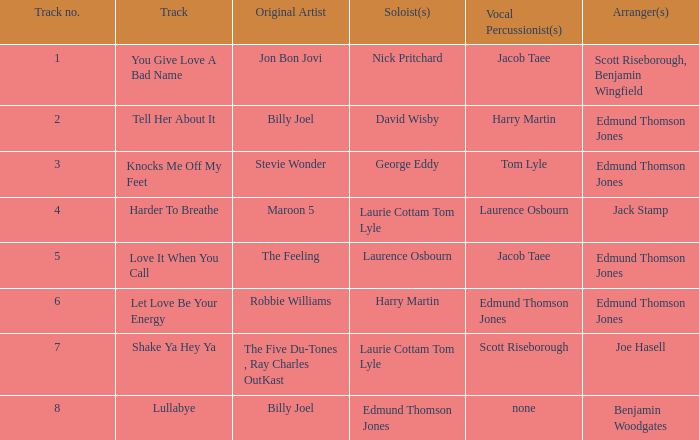Who were the initial artist(s) for track number 6? Robbie Williams. 